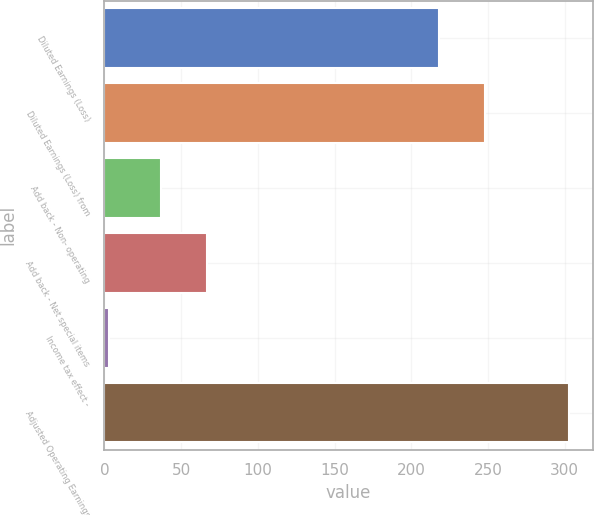<chart> <loc_0><loc_0><loc_500><loc_500><bar_chart><fcel>Diluted Earnings (Loss)<fcel>Diluted Earnings (Loss) from<fcel>Add back - Non- operating<fcel>Add back - Net special items<fcel>Income tax effect -<fcel>Adjusted Operating Earnings<nl><fcel>218<fcel>248<fcel>37<fcel>67<fcel>3<fcel>303<nl></chart> 